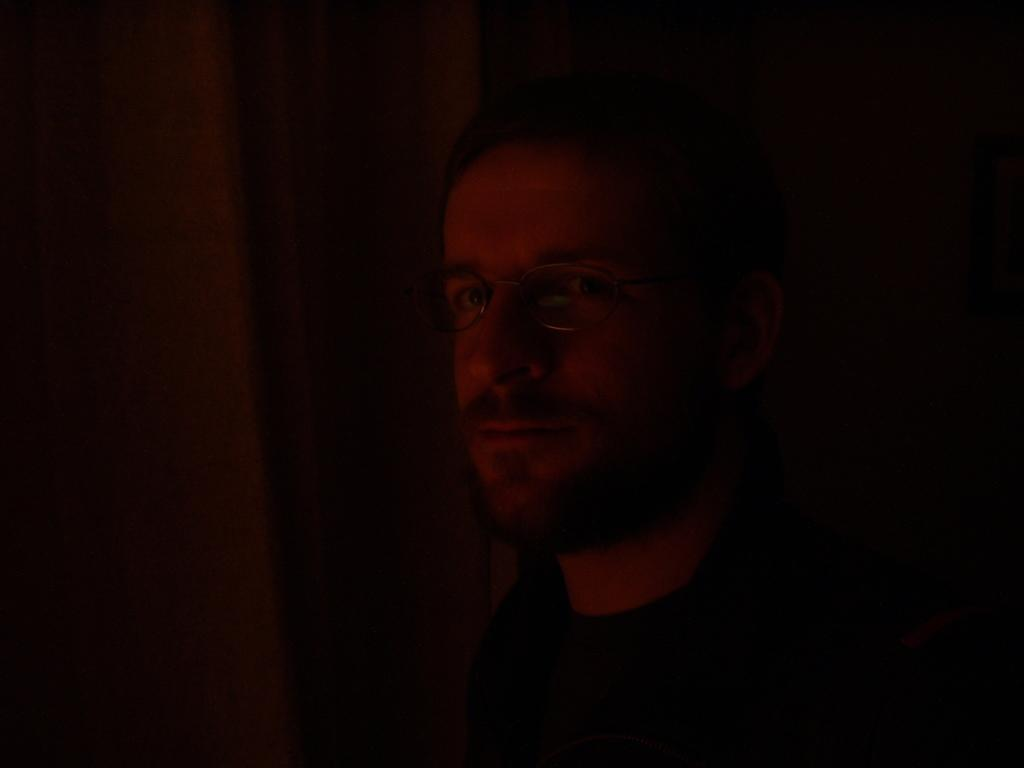Who is present in the image? There is a man in the image. What can be said about the environment in the image? The man is in a dark environment. In which direction is the man facing? The man is facing towards the left side. What is the man looking at? The man is looking at a picture. What type of shoes is the man wearing in the image? There is no information about the man's shoes in the image, so we cannot determine what type of shoes he is wearing. 